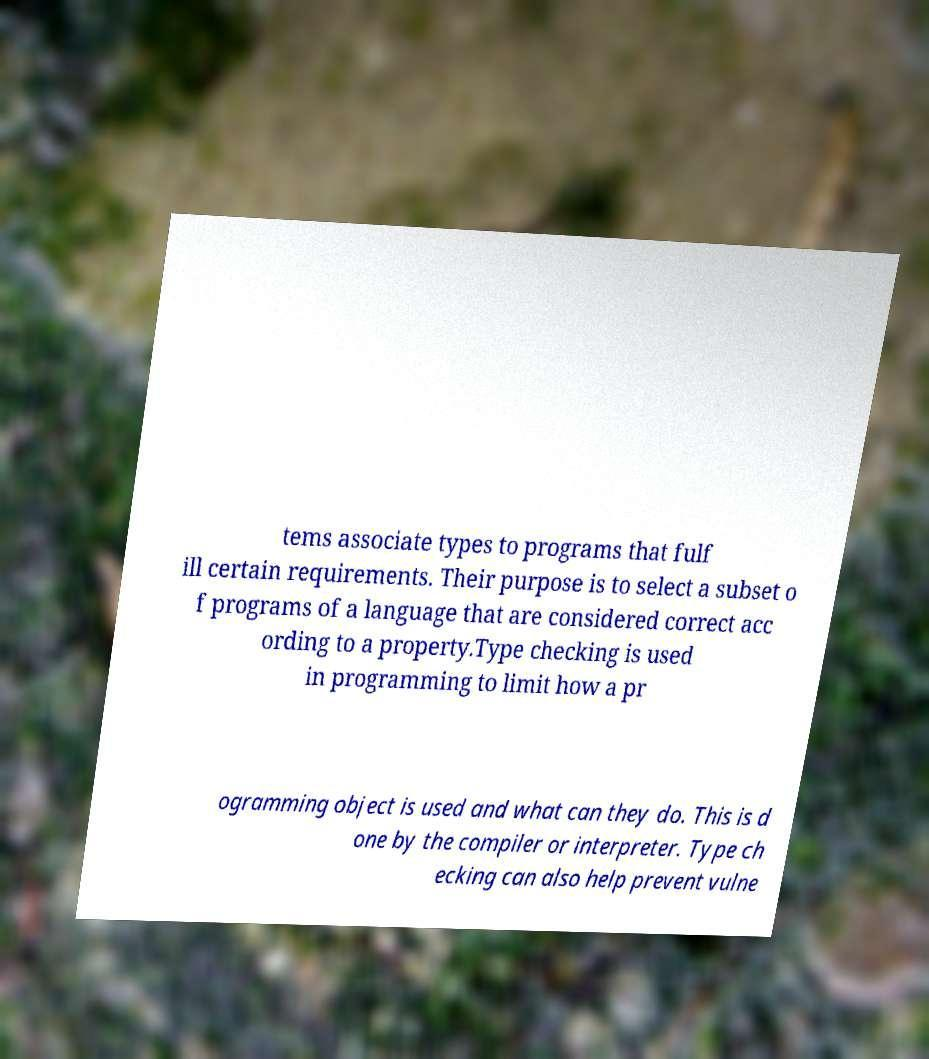Could you extract and type out the text from this image? tems associate types to programs that fulf ill certain requirements. Their purpose is to select a subset o f programs of a language that are considered correct acc ording to a property.Type checking is used in programming to limit how a pr ogramming object is used and what can they do. This is d one by the compiler or interpreter. Type ch ecking can also help prevent vulne 